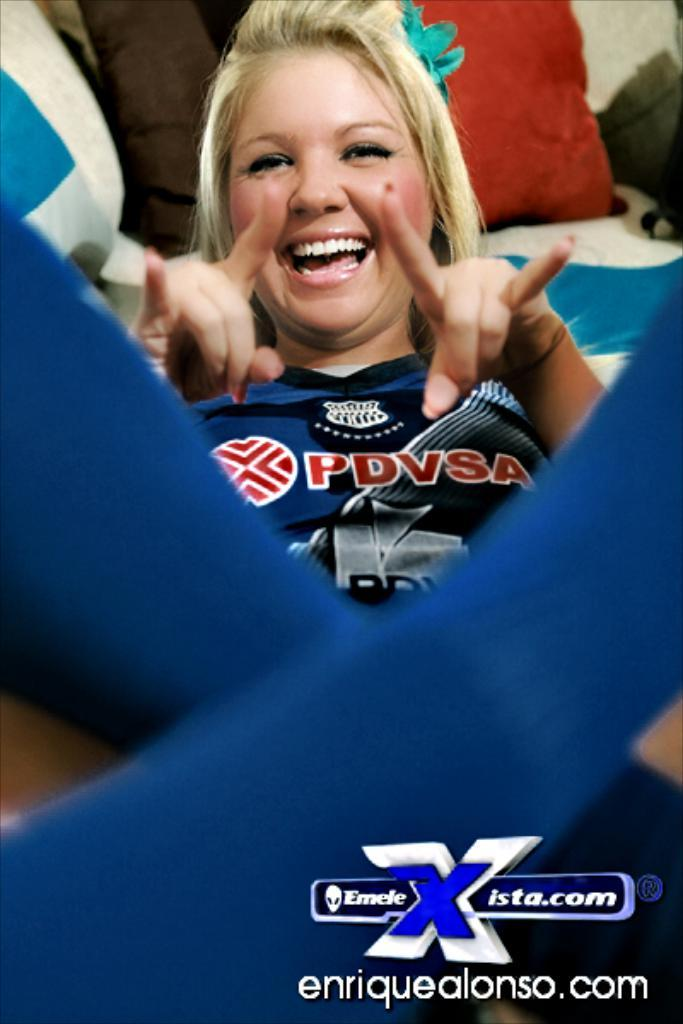What is present in the image? There is a person in the image. What can be seen in the background of the image? There are pillows in the background of the image. What type of leather material can be seen in the image? There is no leather material present in the image. Where might one purchase the items seen in the image? The image does not depict a store or any indication of where the items might be purchased. 